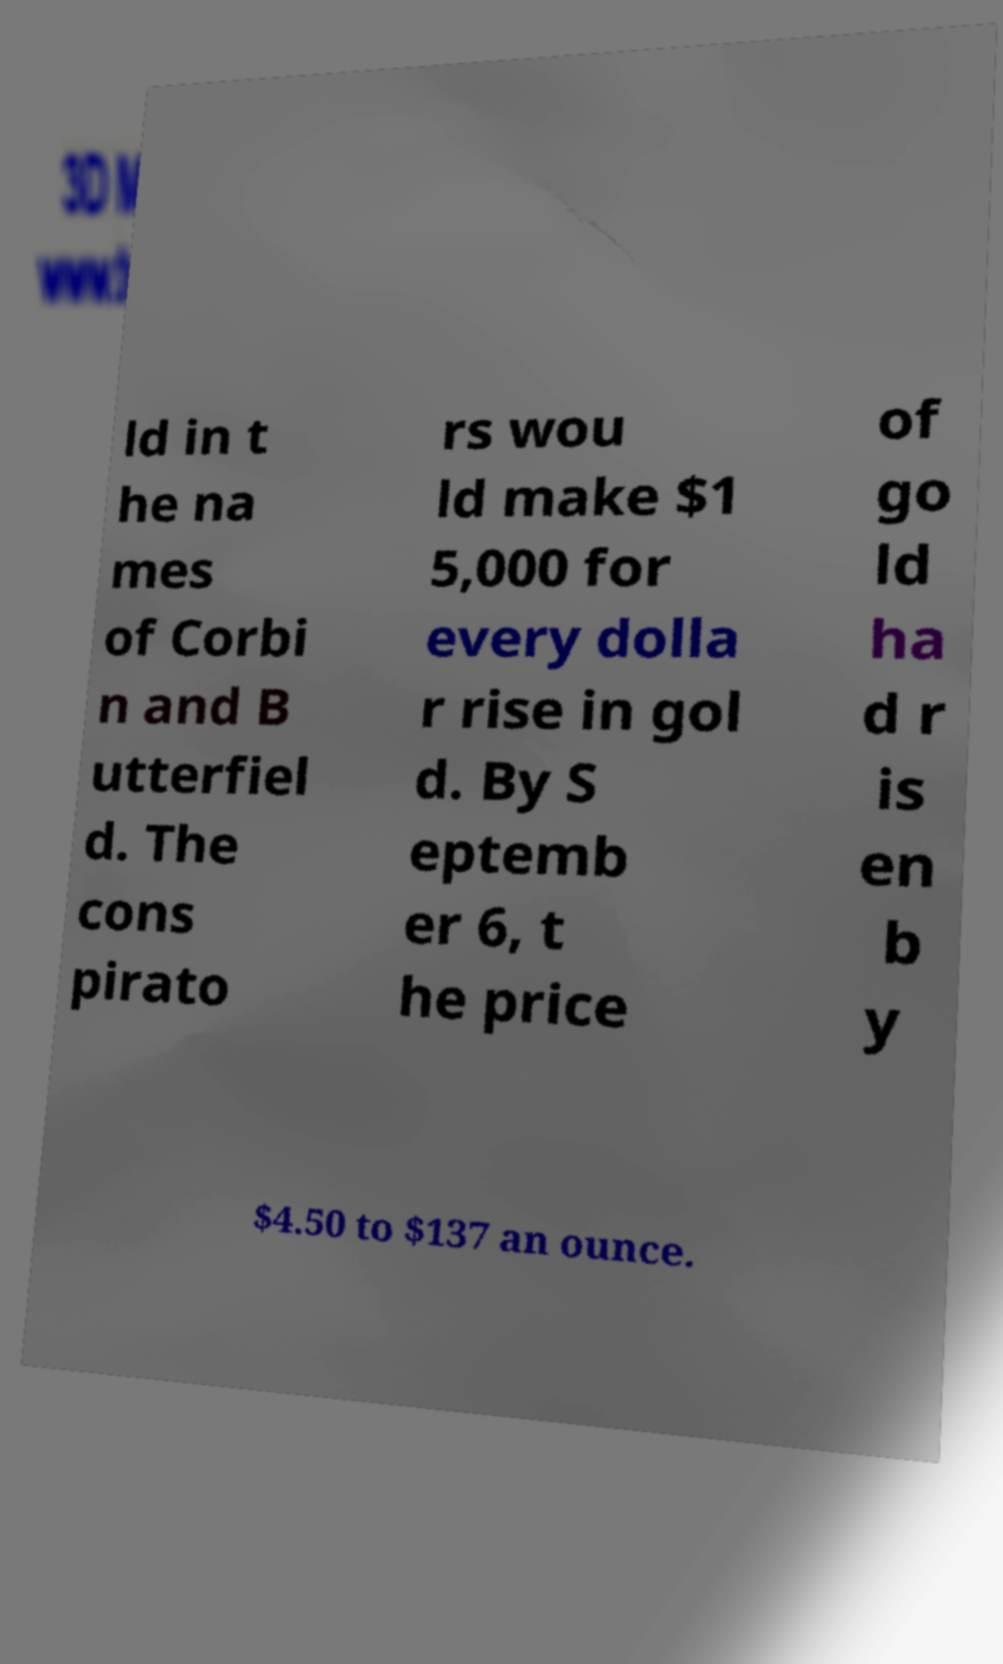What messages or text are displayed in this image? I need them in a readable, typed format. ld in t he na mes of Corbi n and B utterfiel d. The cons pirato rs wou ld make $1 5,000 for every dolla r rise in gol d. By S eptemb er 6, t he price of go ld ha d r is en b y $4.50 to $137 an ounce. 